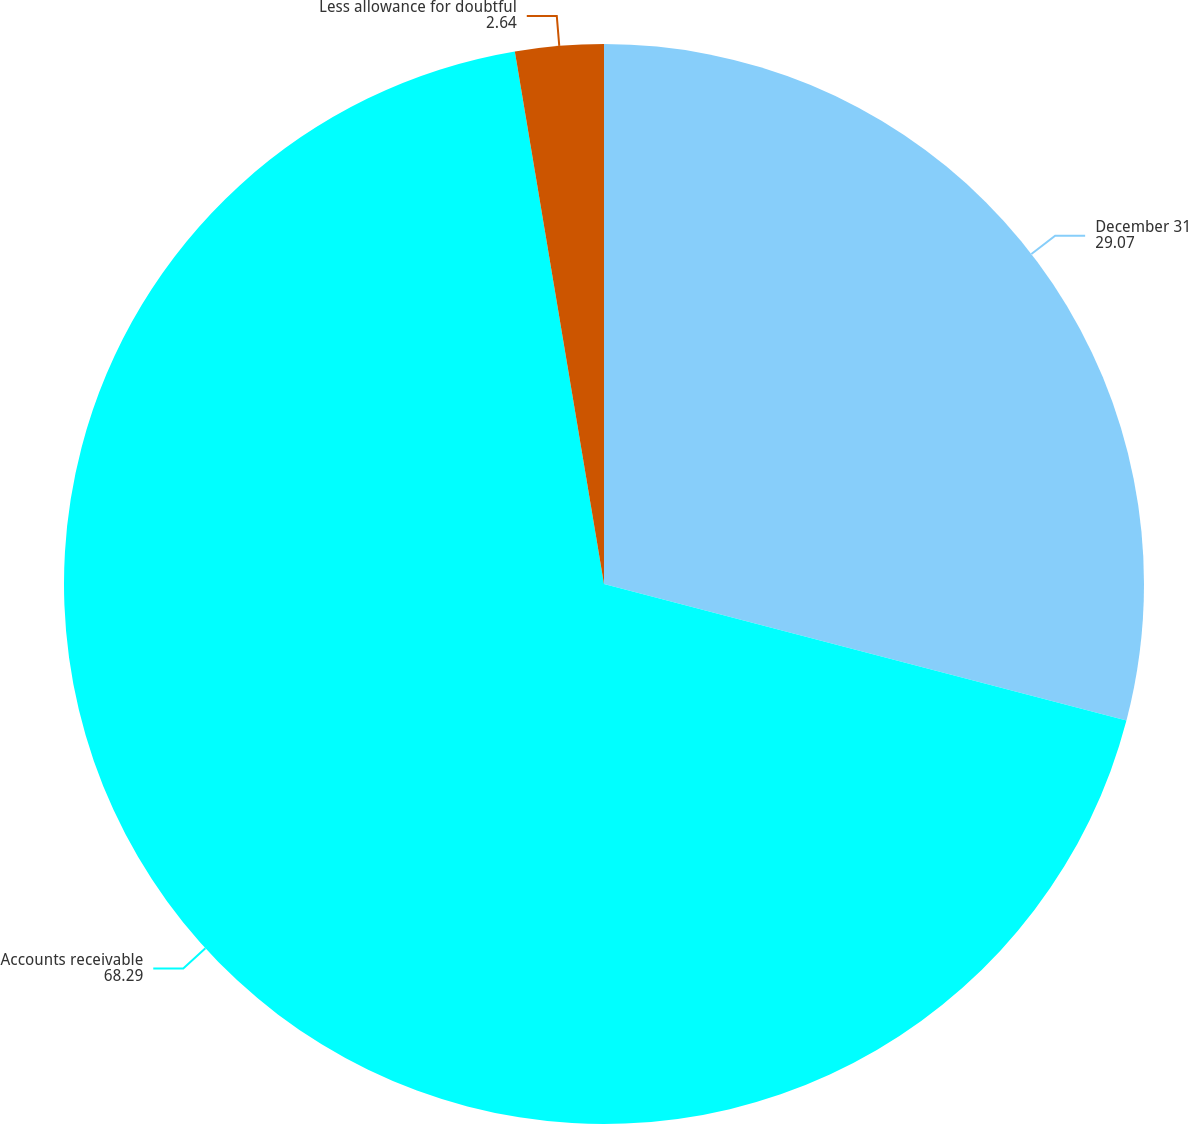Convert chart to OTSL. <chart><loc_0><loc_0><loc_500><loc_500><pie_chart><fcel>December 31<fcel>Accounts receivable<fcel>Less allowance for doubtful<nl><fcel>29.07%<fcel>68.29%<fcel>2.64%<nl></chart> 